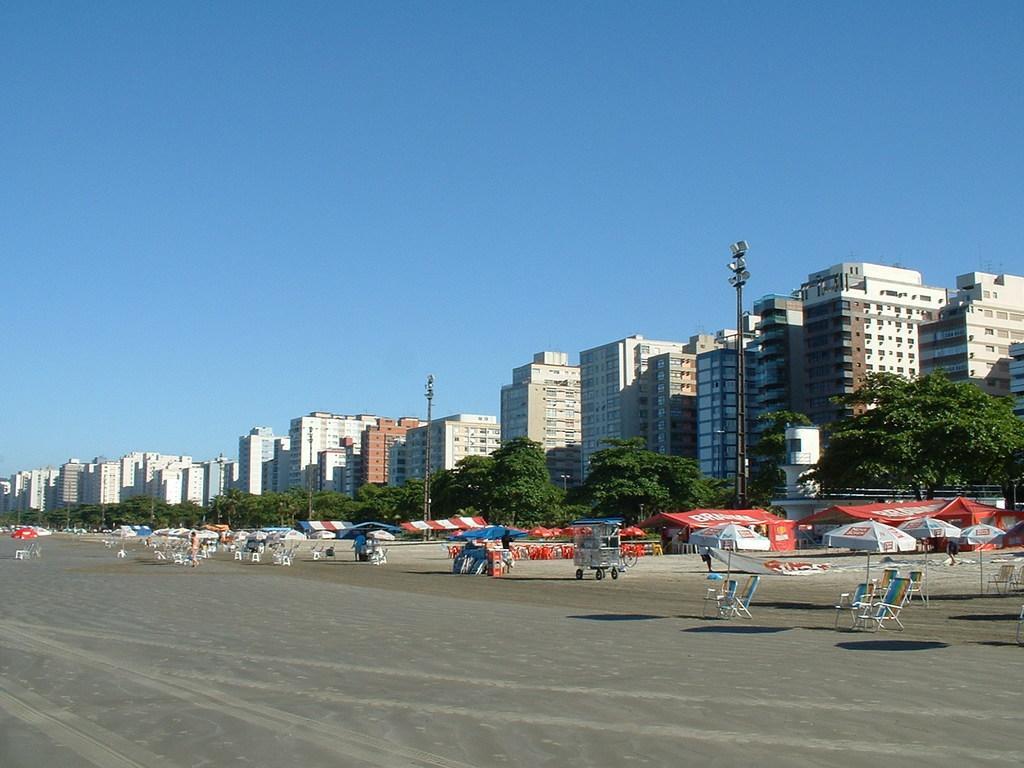Could you give a brief overview of what you see in this image? In this picture we can see chairs, patio umbrellas and cart. There are people and we can see poles, lights, buildings and trees. In the background of the image we can see the sky. 